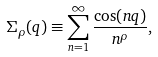Convert formula to latex. <formula><loc_0><loc_0><loc_500><loc_500>\Sigma _ { \rho } ( q ) \equiv \sum _ { n = 1 } ^ { \infty } \frac { \cos ( n q ) } { n ^ { \rho } } ,</formula> 